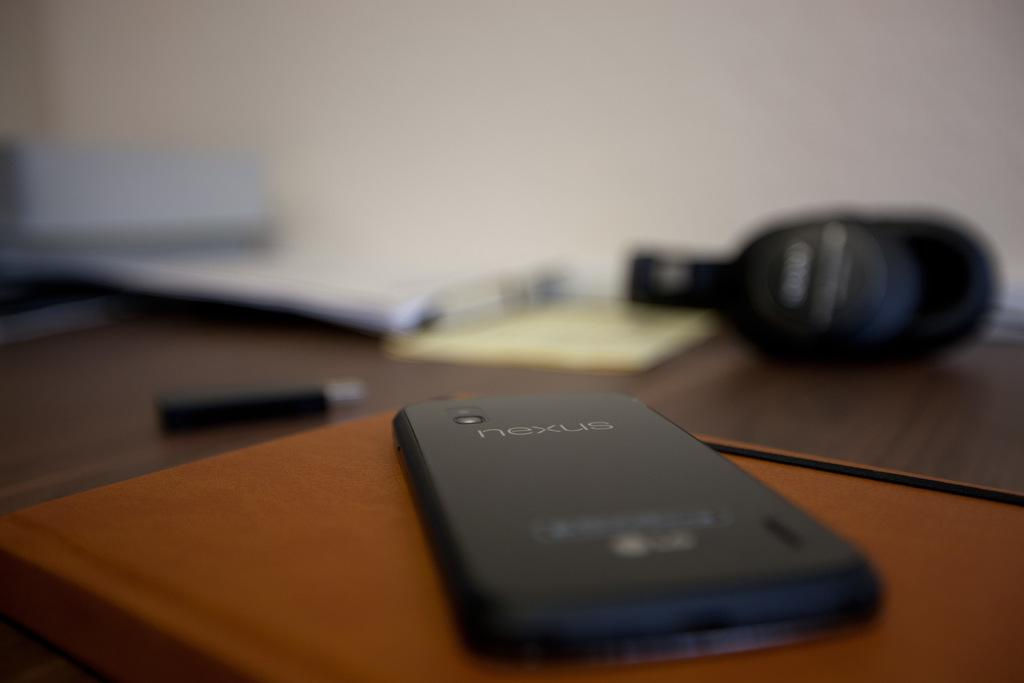<image>
Render a clear and concise summary of the photo. A Nexus phone sits face down on top of a book. 